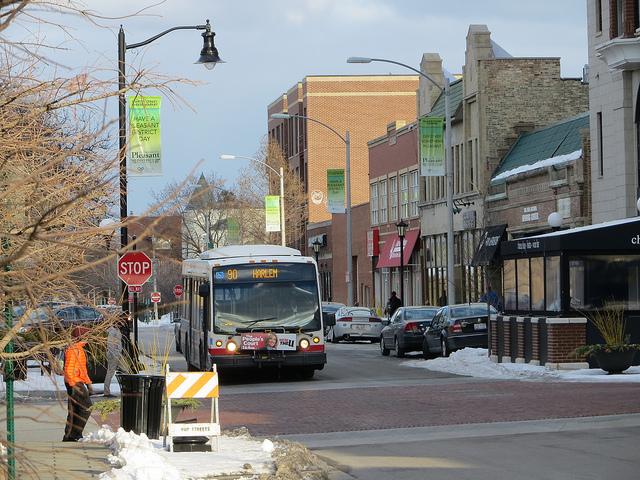What vehicle is the man operating?
Quick response, please. Bus. Is the street busy?
Write a very short answer. No. What is the white stuff on the ground?
Short answer required. Snow. How many people are in the image?
Concise answer only. 2. What is spelled under ML?
Answer briefly. Stop. What vehicles are there?
Keep it brief. Bus. Is there a stop sign in the picture?
Give a very brief answer. Yes. Is the man in the orange top waiting at a bus stop?
Be succinct. No. Is the man jumping?
Quick response, please. No. What is the number on the bus?
Answer briefly. 90. What number is on the building?
Be succinct. 90. Is this a foreign country?
Concise answer only. No. 